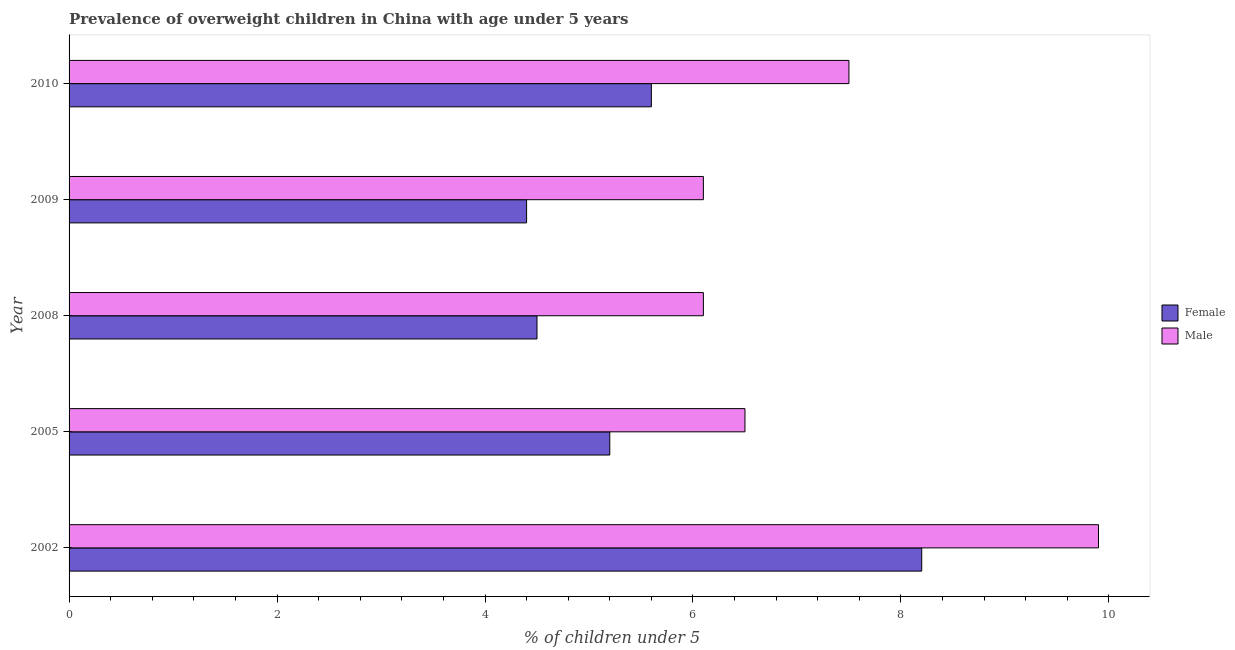How many bars are there on the 1st tick from the top?
Your answer should be very brief. 2. In how many cases, is the number of bars for a given year not equal to the number of legend labels?
Ensure brevity in your answer.  0. Across all years, what is the maximum percentage of obese male children?
Provide a short and direct response. 9.9. Across all years, what is the minimum percentage of obese male children?
Offer a terse response. 6.1. In which year was the percentage of obese female children maximum?
Offer a terse response. 2002. In which year was the percentage of obese male children minimum?
Keep it short and to the point. 2008. What is the total percentage of obese male children in the graph?
Keep it short and to the point. 36.1. What is the difference between the percentage of obese female children in 2002 and that in 2009?
Your response must be concise. 3.8. What is the difference between the percentage of obese male children in 2009 and the percentage of obese female children in 2005?
Your answer should be compact. 0.9. What is the average percentage of obese female children per year?
Offer a very short reply. 5.58. In the year 2009, what is the difference between the percentage of obese male children and percentage of obese female children?
Keep it short and to the point. 1.7. In how many years, is the percentage of obese male children greater than 3.6 %?
Ensure brevity in your answer.  5. What is the ratio of the percentage of obese female children in 2002 to that in 2008?
Your response must be concise. 1.82. Is the difference between the percentage of obese female children in 2005 and 2008 greater than the difference between the percentage of obese male children in 2005 and 2008?
Keep it short and to the point. Yes. What is the difference between the highest and the second highest percentage of obese male children?
Keep it short and to the point. 2.4. What is the difference between the highest and the lowest percentage of obese male children?
Give a very brief answer. 3.8. What does the 1st bar from the top in 2010 represents?
Your response must be concise. Male. What is the difference between two consecutive major ticks on the X-axis?
Your response must be concise. 2. Are the values on the major ticks of X-axis written in scientific E-notation?
Your answer should be compact. No. Does the graph contain any zero values?
Make the answer very short. No. Does the graph contain grids?
Ensure brevity in your answer.  No. Where does the legend appear in the graph?
Provide a succinct answer. Center right. How many legend labels are there?
Your answer should be compact. 2. How are the legend labels stacked?
Ensure brevity in your answer.  Vertical. What is the title of the graph?
Your answer should be very brief. Prevalence of overweight children in China with age under 5 years. Does "Investment in Telecom" appear as one of the legend labels in the graph?
Your answer should be very brief. No. What is the label or title of the X-axis?
Keep it short and to the point.  % of children under 5. What is the  % of children under 5 in Female in 2002?
Provide a succinct answer. 8.2. What is the  % of children under 5 of Male in 2002?
Make the answer very short. 9.9. What is the  % of children under 5 of Female in 2005?
Your answer should be compact. 5.2. What is the  % of children under 5 of Female in 2008?
Offer a very short reply. 4.5. What is the  % of children under 5 of Male in 2008?
Your answer should be very brief. 6.1. What is the  % of children under 5 in Female in 2009?
Offer a very short reply. 4.4. What is the  % of children under 5 in Male in 2009?
Your answer should be very brief. 6.1. What is the  % of children under 5 in Female in 2010?
Your response must be concise. 5.6. Across all years, what is the maximum  % of children under 5 of Female?
Offer a very short reply. 8.2. Across all years, what is the maximum  % of children under 5 of Male?
Offer a terse response. 9.9. Across all years, what is the minimum  % of children under 5 in Female?
Your answer should be compact. 4.4. Across all years, what is the minimum  % of children under 5 in Male?
Give a very brief answer. 6.1. What is the total  % of children under 5 in Female in the graph?
Your answer should be very brief. 27.9. What is the total  % of children under 5 of Male in the graph?
Offer a terse response. 36.1. What is the difference between the  % of children under 5 in Male in 2002 and that in 2005?
Give a very brief answer. 3.4. What is the difference between the  % of children under 5 in Female in 2002 and that in 2008?
Your answer should be compact. 3.7. What is the difference between the  % of children under 5 in Female in 2002 and that in 2010?
Your answer should be very brief. 2.6. What is the difference between the  % of children under 5 in Male in 2002 and that in 2010?
Your answer should be very brief. 2.4. What is the difference between the  % of children under 5 of Male in 2005 and that in 2008?
Provide a short and direct response. 0.4. What is the difference between the  % of children under 5 in Male in 2005 and that in 2009?
Offer a very short reply. 0.4. What is the difference between the  % of children under 5 of Female in 2005 and that in 2010?
Ensure brevity in your answer.  -0.4. What is the difference between the  % of children under 5 of Male in 2005 and that in 2010?
Provide a short and direct response. -1. What is the difference between the  % of children under 5 in Female in 2008 and that in 2009?
Provide a short and direct response. 0.1. What is the difference between the  % of children under 5 in Female in 2008 and that in 2010?
Give a very brief answer. -1.1. What is the difference between the  % of children under 5 in Female in 2009 and that in 2010?
Offer a very short reply. -1.2. What is the difference between the  % of children under 5 in Female in 2002 and the  % of children under 5 in Male in 2005?
Your response must be concise. 1.7. What is the difference between the  % of children under 5 of Female in 2002 and the  % of children under 5 of Male in 2009?
Offer a terse response. 2.1. What is the difference between the  % of children under 5 of Female in 2002 and the  % of children under 5 of Male in 2010?
Provide a short and direct response. 0.7. What is the difference between the  % of children under 5 of Female in 2005 and the  % of children under 5 of Male in 2008?
Offer a terse response. -0.9. What is the difference between the  % of children under 5 in Female in 2005 and the  % of children under 5 in Male in 2009?
Your answer should be very brief. -0.9. What is the difference between the  % of children under 5 of Female in 2005 and the  % of children under 5 of Male in 2010?
Offer a very short reply. -2.3. What is the difference between the  % of children under 5 of Female in 2008 and the  % of children under 5 of Male in 2009?
Offer a very short reply. -1.6. What is the difference between the  % of children under 5 in Female in 2009 and the  % of children under 5 in Male in 2010?
Offer a very short reply. -3.1. What is the average  % of children under 5 in Female per year?
Your answer should be very brief. 5.58. What is the average  % of children under 5 of Male per year?
Your response must be concise. 7.22. In the year 2002, what is the difference between the  % of children under 5 of Female and  % of children under 5 of Male?
Provide a succinct answer. -1.7. In the year 2008, what is the difference between the  % of children under 5 in Female and  % of children under 5 in Male?
Your answer should be compact. -1.6. In the year 2009, what is the difference between the  % of children under 5 in Female and  % of children under 5 in Male?
Ensure brevity in your answer.  -1.7. In the year 2010, what is the difference between the  % of children under 5 of Female and  % of children under 5 of Male?
Your response must be concise. -1.9. What is the ratio of the  % of children under 5 of Female in 2002 to that in 2005?
Provide a succinct answer. 1.58. What is the ratio of the  % of children under 5 of Male in 2002 to that in 2005?
Keep it short and to the point. 1.52. What is the ratio of the  % of children under 5 in Female in 2002 to that in 2008?
Offer a very short reply. 1.82. What is the ratio of the  % of children under 5 of Male in 2002 to that in 2008?
Your response must be concise. 1.62. What is the ratio of the  % of children under 5 in Female in 2002 to that in 2009?
Your answer should be very brief. 1.86. What is the ratio of the  % of children under 5 of Male in 2002 to that in 2009?
Keep it short and to the point. 1.62. What is the ratio of the  % of children under 5 in Female in 2002 to that in 2010?
Give a very brief answer. 1.46. What is the ratio of the  % of children under 5 in Male in 2002 to that in 2010?
Keep it short and to the point. 1.32. What is the ratio of the  % of children under 5 of Female in 2005 to that in 2008?
Your response must be concise. 1.16. What is the ratio of the  % of children under 5 of Male in 2005 to that in 2008?
Your answer should be very brief. 1.07. What is the ratio of the  % of children under 5 of Female in 2005 to that in 2009?
Offer a very short reply. 1.18. What is the ratio of the  % of children under 5 in Male in 2005 to that in 2009?
Provide a short and direct response. 1.07. What is the ratio of the  % of children under 5 of Female in 2005 to that in 2010?
Your answer should be compact. 0.93. What is the ratio of the  % of children under 5 in Male in 2005 to that in 2010?
Your answer should be compact. 0.87. What is the ratio of the  % of children under 5 of Female in 2008 to that in 2009?
Provide a short and direct response. 1.02. What is the ratio of the  % of children under 5 in Male in 2008 to that in 2009?
Make the answer very short. 1. What is the ratio of the  % of children under 5 of Female in 2008 to that in 2010?
Ensure brevity in your answer.  0.8. What is the ratio of the  % of children under 5 of Male in 2008 to that in 2010?
Offer a very short reply. 0.81. What is the ratio of the  % of children under 5 in Female in 2009 to that in 2010?
Give a very brief answer. 0.79. What is the ratio of the  % of children under 5 in Male in 2009 to that in 2010?
Offer a very short reply. 0.81. What is the difference between the highest and the second highest  % of children under 5 in Male?
Your answer should be very brief. 2.4. What is the difference between the highest and the lowest  % of children under 5 in Male?
Your answer should be compact. 3.8. 